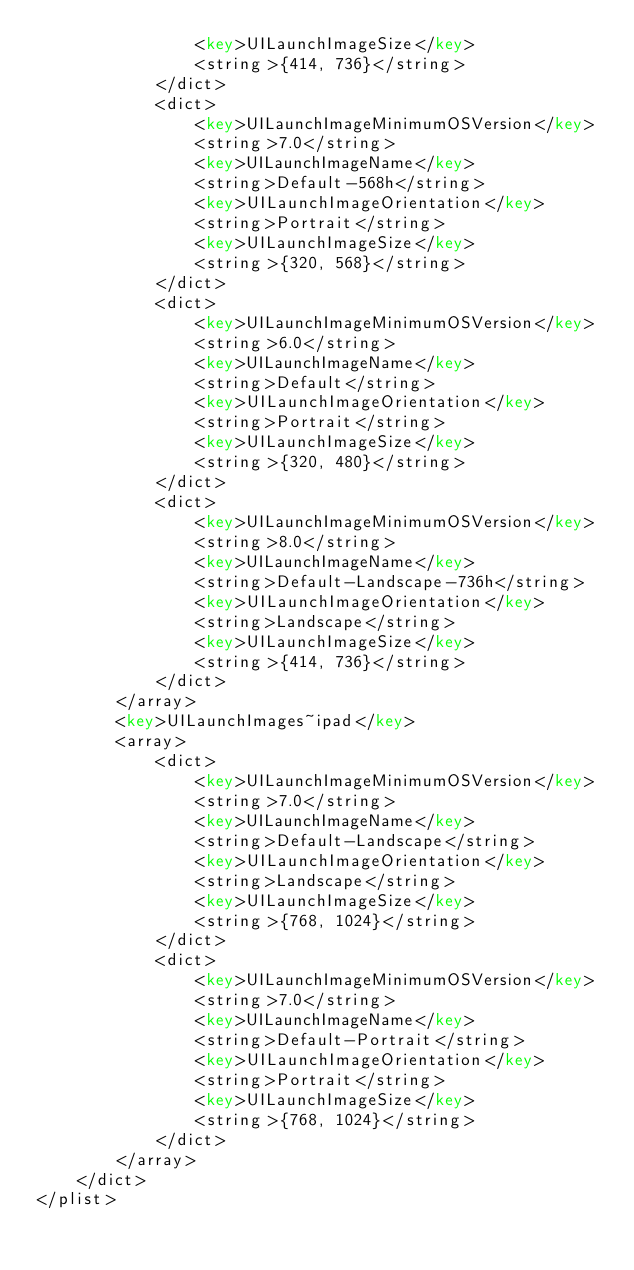Convert code to text. <code><loc_0><loc_0><loc_500><loc_500><_XML_>				<key>UILaunchImageSize</key>
				<string>{414, 736}</string>
			</dict>
			<dict>
				<key>UILaunchImageMinimumOSVersion</key>
				<string>7.0</string>
				<key>UILaunchImageName</key>
				<string>Default-568h</string>
				<key>UILaunchImageOrientation</key>
				<string>Portrait</string>
				<key>UILaunchImageSize</key>
				<string>{320, 568}</string>
			</dict>
			<dict>
				<key>UILaunchImageMinimumOSVersion</key>
				<string>6.0</string>
				<key>UILaunchImageName</key>
				<string>Default</string>
				<key>UILaunchImageOrientation</key>
				<string>Portrait</string>
				<key>UILaunchImageSize</key>
				<string>{320, 480}</string>
			</dict>
			<dict>
				<key>UILaunchImageMinimumOSVersion</key>
				<string>8.0</string>
				<key>UILaunchImageName</key>
				<string>Default-Landscape-736h</string>
				<key>UILaunchImageOrientation</key>
				<string>Landscape</string>
				<key>UILaunchImageSize</key>
				<string>{414, 736}</string>
			</dict>
		</array>
		<key>UILaunchImages~ipad</key>
		<array>
			<dict>
				<key>UILaunchImageMinimumOSVersion</key>
				<string>7.0</string>
				<key>UILaunchImageName</key>
				<string>Default-Landscape</string>
				<key>UILaunchImageOrientation</key>
				<string>Landscape</string>
				<key>UILaunchImageSize</key>
				<string>{768, 1024}</string>
			</dict>
			<dict>
				<key>UILaunchImageMinimumOSVersion</key>
				<string>7.0</string>
				<key>UILaunchImageName</key>
				<string>Default-Portrait</string>
				<key>UILaunchImageOrientation</key>
				<string>Portrait</string>
				<key>UILaunchImageSize</key>
				<string>{768, 1024}</string>
			</dict>
		</array>
	</dict>
</plist>
</code> 